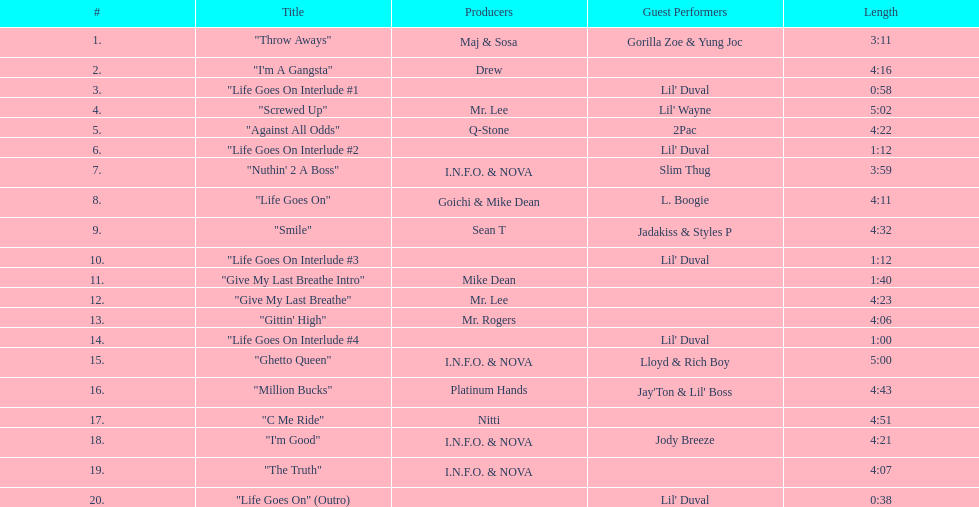Could you parse the entire table? {'header': ['#', 'Title', 'Producers', 'Guest Performers', 'Length'], 'rows': [['1.', '"Throw Aways"', 'Maj & Sosa', 'Gorilla Zoe & Yung Joc', '3:11'], ['2.', '"I\'m A Gangsta"', 'Drew', '', '4:16'], ['3.', '"Life Goes On Interlude #1', '', "Lil' Duval", '0:58'], ['4.', '"Screwed Up"', 'Mr. Lee', "Lil' Wayne", '5:02'], ['5.', '"Against All Odds"', 'Q-Stone', '2Pac', '4:22'], ['6.', '"Life Goes On Interlude #2', '', "Lil' Duval", '1:12'], ['7.', '"Nuthin\' 2 A Boss"', 'I.N.F.O. & NOVA', 'Slim Thug', '3:59'], ['8.', '"Life Goes On"', 'Goichi & Mike Dean', 'L. Boogie', '4:11'], ['9.', '"Smile"', 'Sean T', 'Jadakiss & Styles P', '4:32'], ['10.', '"Life Goes On Interlude #3', '', "Lil' Duval", '1:12'], ['11.', '"Give My Last Breathe Intro"', 'Mike Dean', '', '1:40'], ['12.', '"Give My Last Breathe"', 'Mr. Lee', '', '4:23'], ['13.', '"Gittin\' High"', 'Mr. Rogers', '', '4:06'], ['14.', '"Life Goes On Interlude #4', '', "Lil' Duval", '1:00'], ['15.', '"Ghetto Queen"', 'I.N.F.O. & NOVA', 'Lloyd & Rich Boy', '5:00'], ['16.', '"Million Bucks"', 'Platinum Hands', "Jay'Ton & Lil' Boss", '4:43'], ['17.', '"C Me Ride"', 'Nitti', '', '4:51'], ['18.', '"I\'m Good"', 'I.N.F.O. & NOVA', 'Jody Breeze', '4:21'], ['19.', '"The Truth"', 'I.N.F.O. & NOVA', '', '4:07'], ['20.', '"Life Goes On" (Outro)', '', "Lil' Duval", '0:38']]} In how many tracks does 2pac make an appearance? 1. 